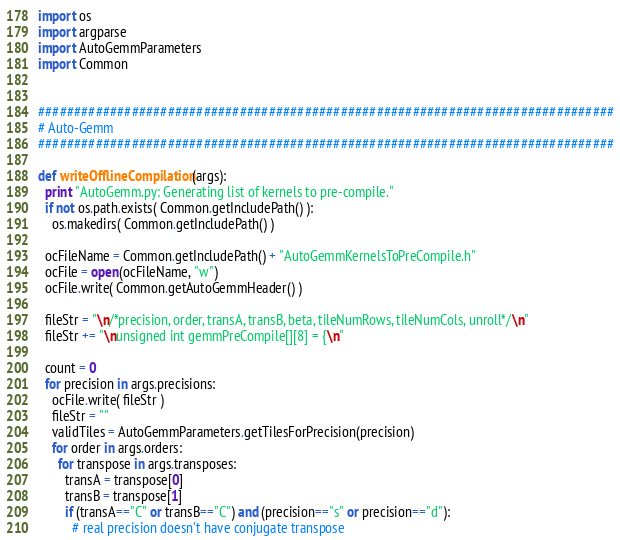Convert code to text. <code><loc_0><loc_0><loc_500><loc_500><_Python_>import os
import argparse
import AutoGemmParameters
import Common


################################################################################
# Auto-Gemm
################################################################################

def writeOfflineCompilation(args):
  print "AutoGemm.py: Generating list of kernels to pre-compile."
  if not os.path.exists( Common.getIncludePath() ):
    os.makedirs( Common.getIncludePath() )

  ocFileName = Common.getIncludePath() + "AutoGemmKernelsToPreCompile.h"
  ocFile = open(ocFileName, "w")
  ocFile.write( Common.getAutoGemmHeader() )

  fileStr = "\n/*precision, order, transA, transB, beta, tileNumRows, tileNumCols, unroll*/\n"
  fileStr += "\nunsigned int gemmPreCompile[][8] = {\n"

  count = 0
  for precision in args.precisions:
    ocFile.write( fileStr )
    fileStr = ""
    validTiles = AutoGemmParameters.getTilesForPrecision(precision)
    for order in args.orders:
      for transpose in args.transposes:
        transA = transpose[0]
        transB = transpose[1]
        if (transA=="C" or transB=="C") and (precision=="s" or precision=="d"):
          # real precision doesn't have conjugate transpose</code> 